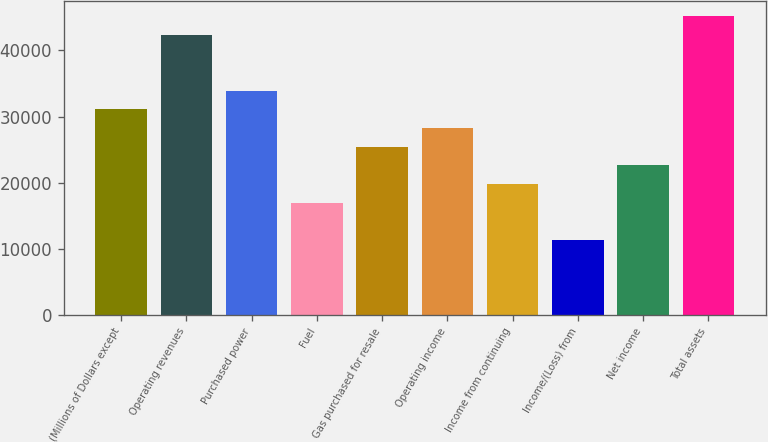Convert chart to OTSL. <chart><loc_0><loc_0><loc_500><loc_500><bar_chart><fcel>(Millions of Dollars except<fcel>Operating revenues<fcel>Purchased power<fcel>Fuel<fcel>Gas purchased for resale<fcel>Operating income<fcel>Income from continuing<fcel>Income/(Loss) from<fcel>Net income<fcel>Total assets<nl><fcel>31088.2<fcel>42393<fcel>33914.4<fcel>16957.2<fcel>25435.8<fcel>28262<fcel>19783.4<fcel>11304.8<fcel>22609.6<fcel>45219.2<nl></chart> 